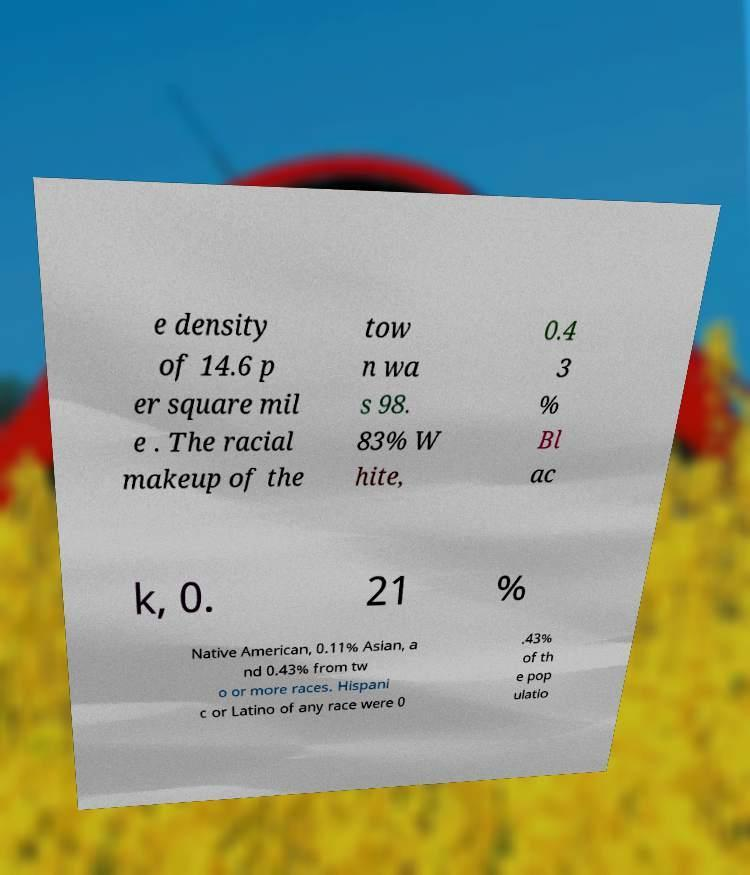For documentation purposes, I need the text within this image transcribed. Could you provide that? e density of 14.6 p er square mil e . The racial makeup of the tow n wa s 98. 83% W hite, 0.4 3 % Bl ac k, 0. 21 % Native American, 0.11% Asian, a nd 0.43% from tw o or more races. Hispani c or Latino of any race were 0 .43% of th e pop ulatio 